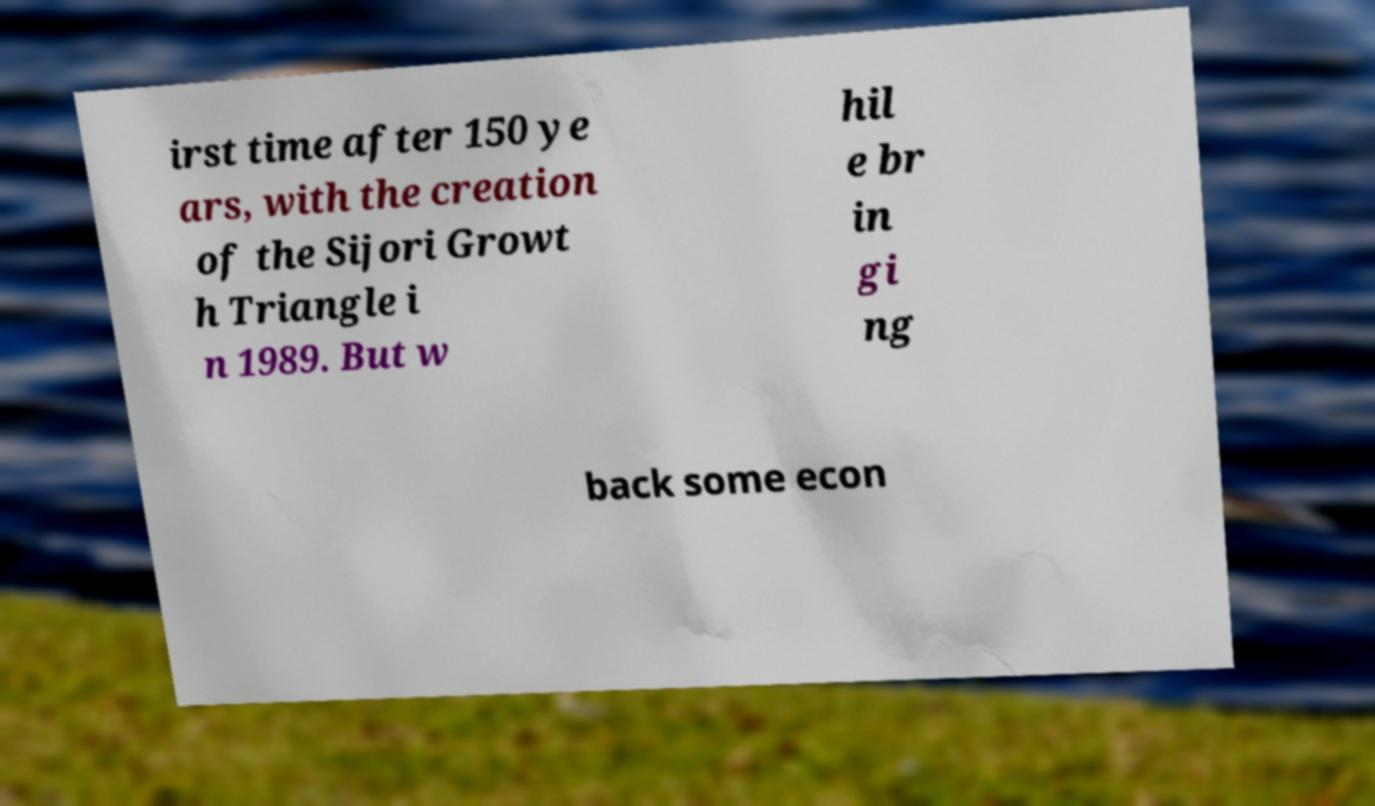Can you read and provide the text displayed in the image?This photo seems to have some interesting text. Can you extract and type it out for me? irst time after 150 ye ars, with the creation of the Sijori Growt h Triangle i n 1989. But w hil e br in gi ng back some econ 